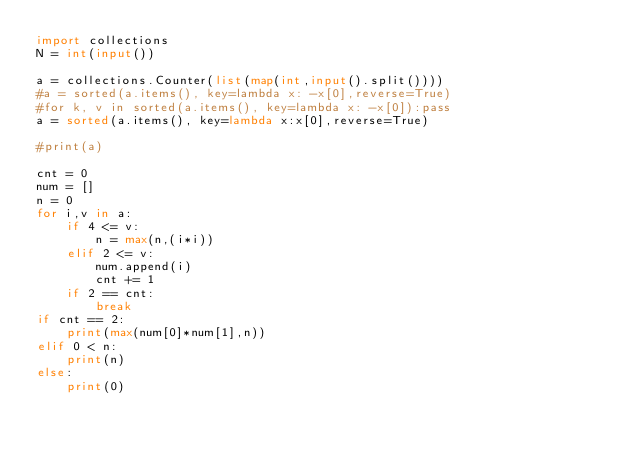<code> <loc_0><loc_0><loc_500><loc_500><_Python_>import collections
N = int(input())

a = collections.Counter(list(map(int,input().split())))
#a = sorted(a.items(), key=lambda x: -x[0],reverse=True)
#for k, v in sorted(a.items(), key=lambda x: -x[0]):pass
a = sorted(a.items(), key=lambda x:x[0],reverse=True)

#print(a)

cnt = 0
num = []
n = 0
for i,v in a:
    if 4 <= v:
        n = max(n,(i*i))
    elif 2 <= v:
        num.append(i)
        cnt += 1
    if 2 == cnt:
        break
if cnt == 2:
    print(max(num[0]*num[1],n))
elif 0 < n:
    print(n)
else:
    print(0)
</code> 